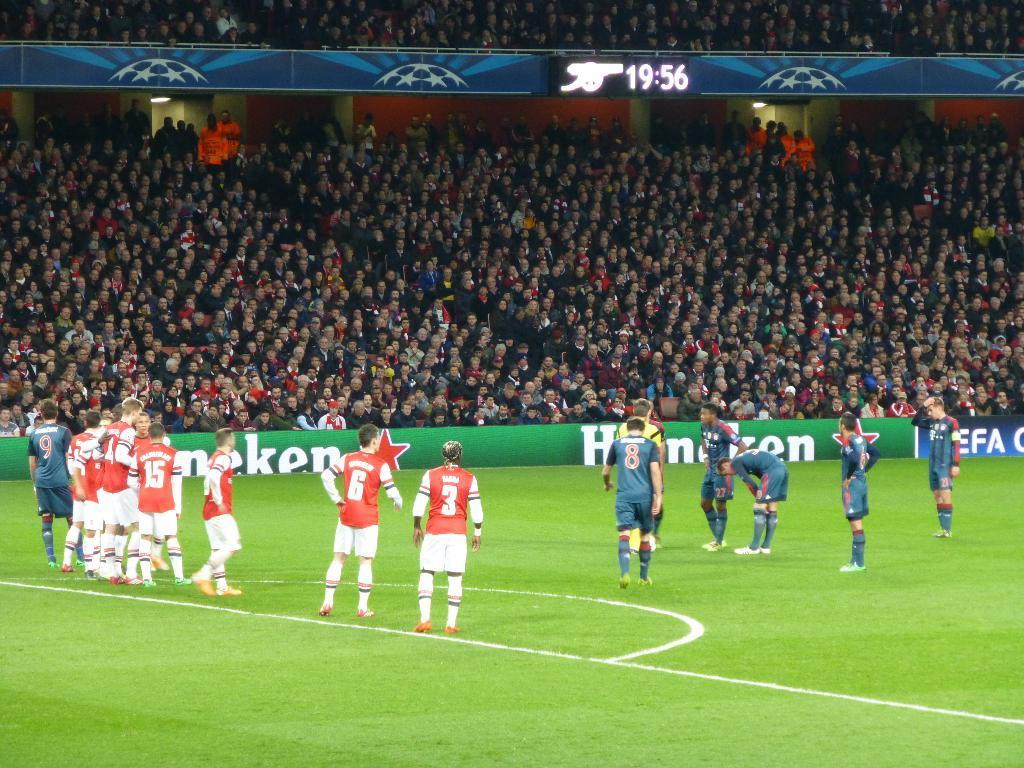How many people are in the image? There is a group of people in the image, but the exact number is not specified. What are the people in the image doing? Some people are standing, while others are sitting on chairs. What can be seen in the background of the image? There is a fence in the image, and the grass is visible. What markings are on the ground in the image? There are white color lines on the ground. What type of food is being served in the lunchroom in the image? There is no mention of a lunchroom or food in the image; it features a group of people with some standing and others sitting, along with a fence, grass, and white color lines on the ground. 